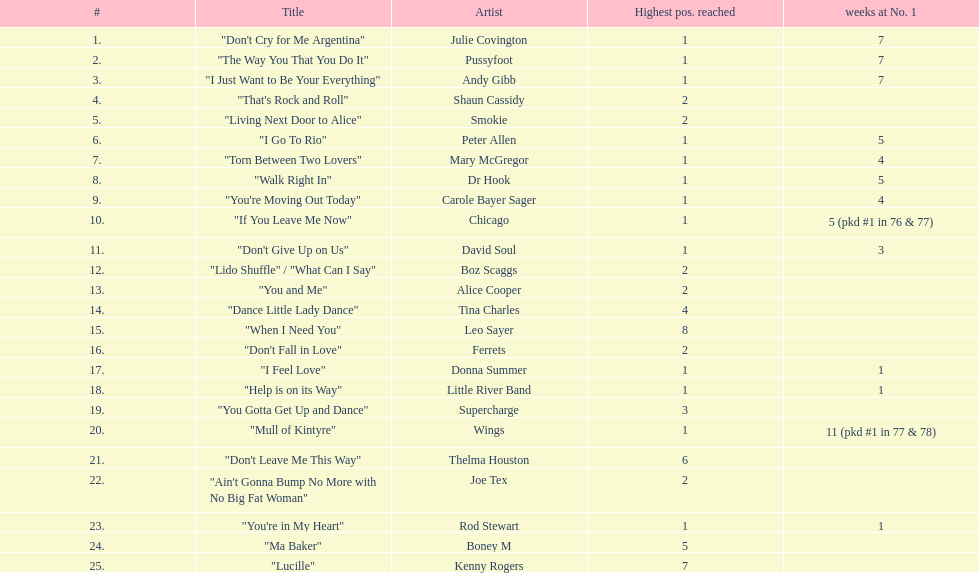Who held the top position for the longest time, as per the chart? Wings. 